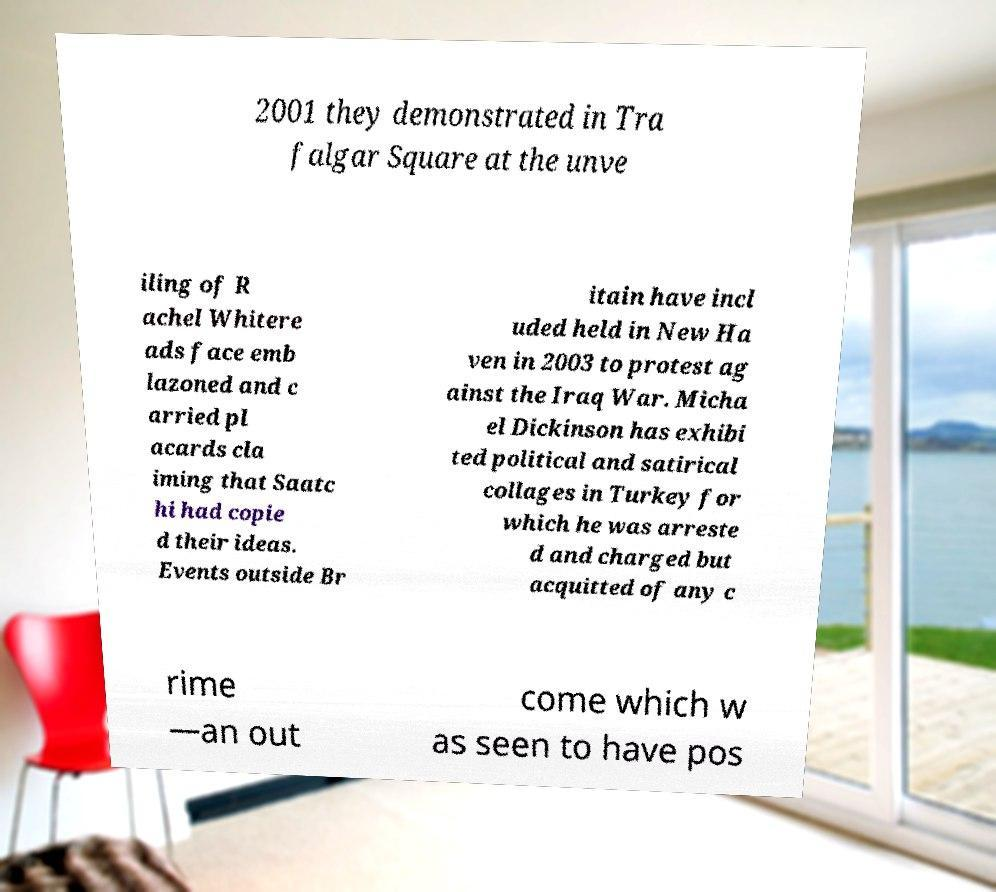Can you read and provide the text displayed in the image?This photo seems to have some interesting text. Can you extract and type it out for me? 2001 they demonstrated in Tra falgar Square at the unve iling of R achel Whitere ads face emb lazoned and c arried pl acards cla iming that Saatc hi had copie d their ideas. Events outside Br itain have incl uded held in New Ha ven in 2003 to protest ag ainst the Iraq War. Micha el Dickinson has exhibi ted political and satirical collages in Turkey for which he was arreste d and charged but acquitted of any c rime —an out come which w as seen to have pos 